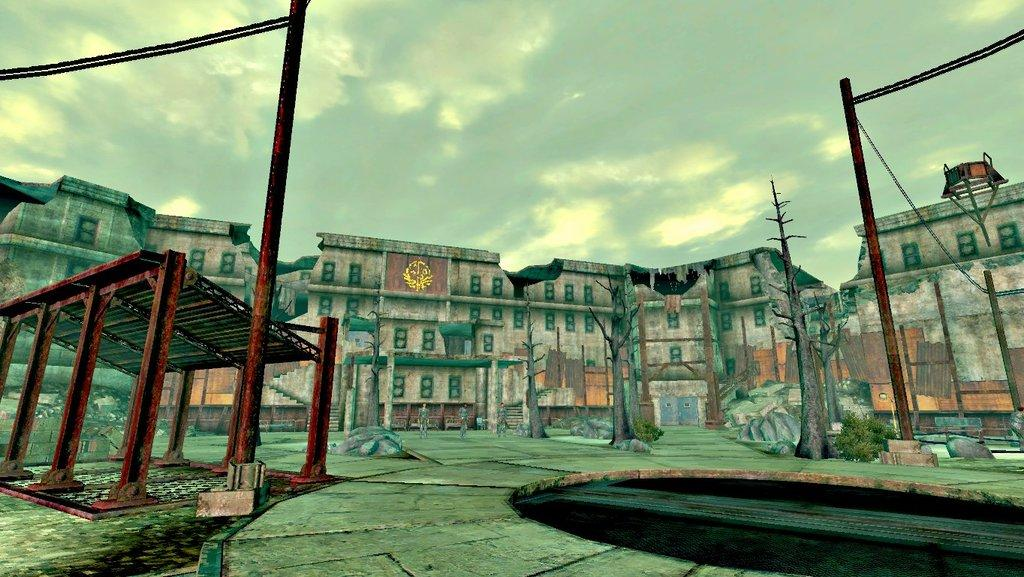What type of image is being described? The image is animated. How many persons are in the middle of the image? There are three persons in the middle of the image. What can be seen in the background of the image? There are buildings, trees, plants, and poles in the background of the image. What is visible at the top of the image? The sky is visible at the top of the image. Can you tell me who won the argument between the two characters in the image? There is no argument depicted in the image; it features three animated persons in the middle of the image with a background of buildings, trees, plants, and poles. 